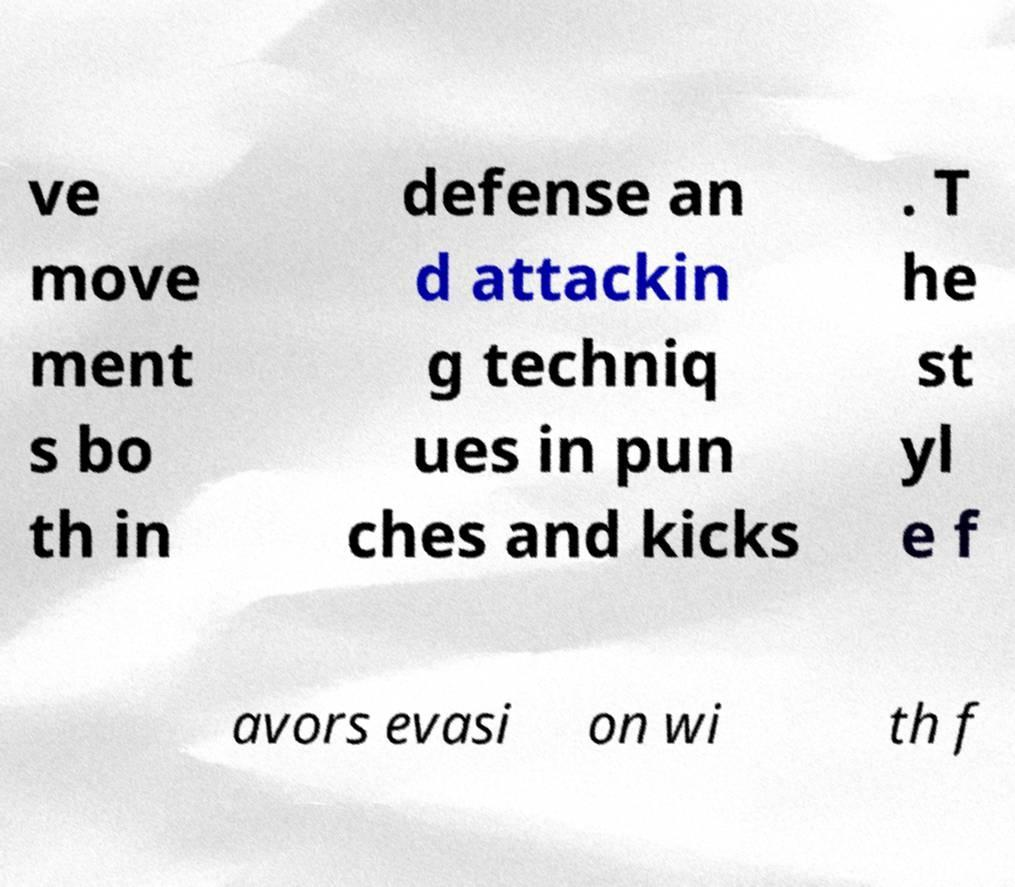Can you read and provide the text displayed in the image?This photo seems to have some interesting text. Can you extract and type it out for me? ve move ment s bo th in defense an d attackin g techniq ues in pun ches and kicks . T he st yl e f avors evasi on wi th f 